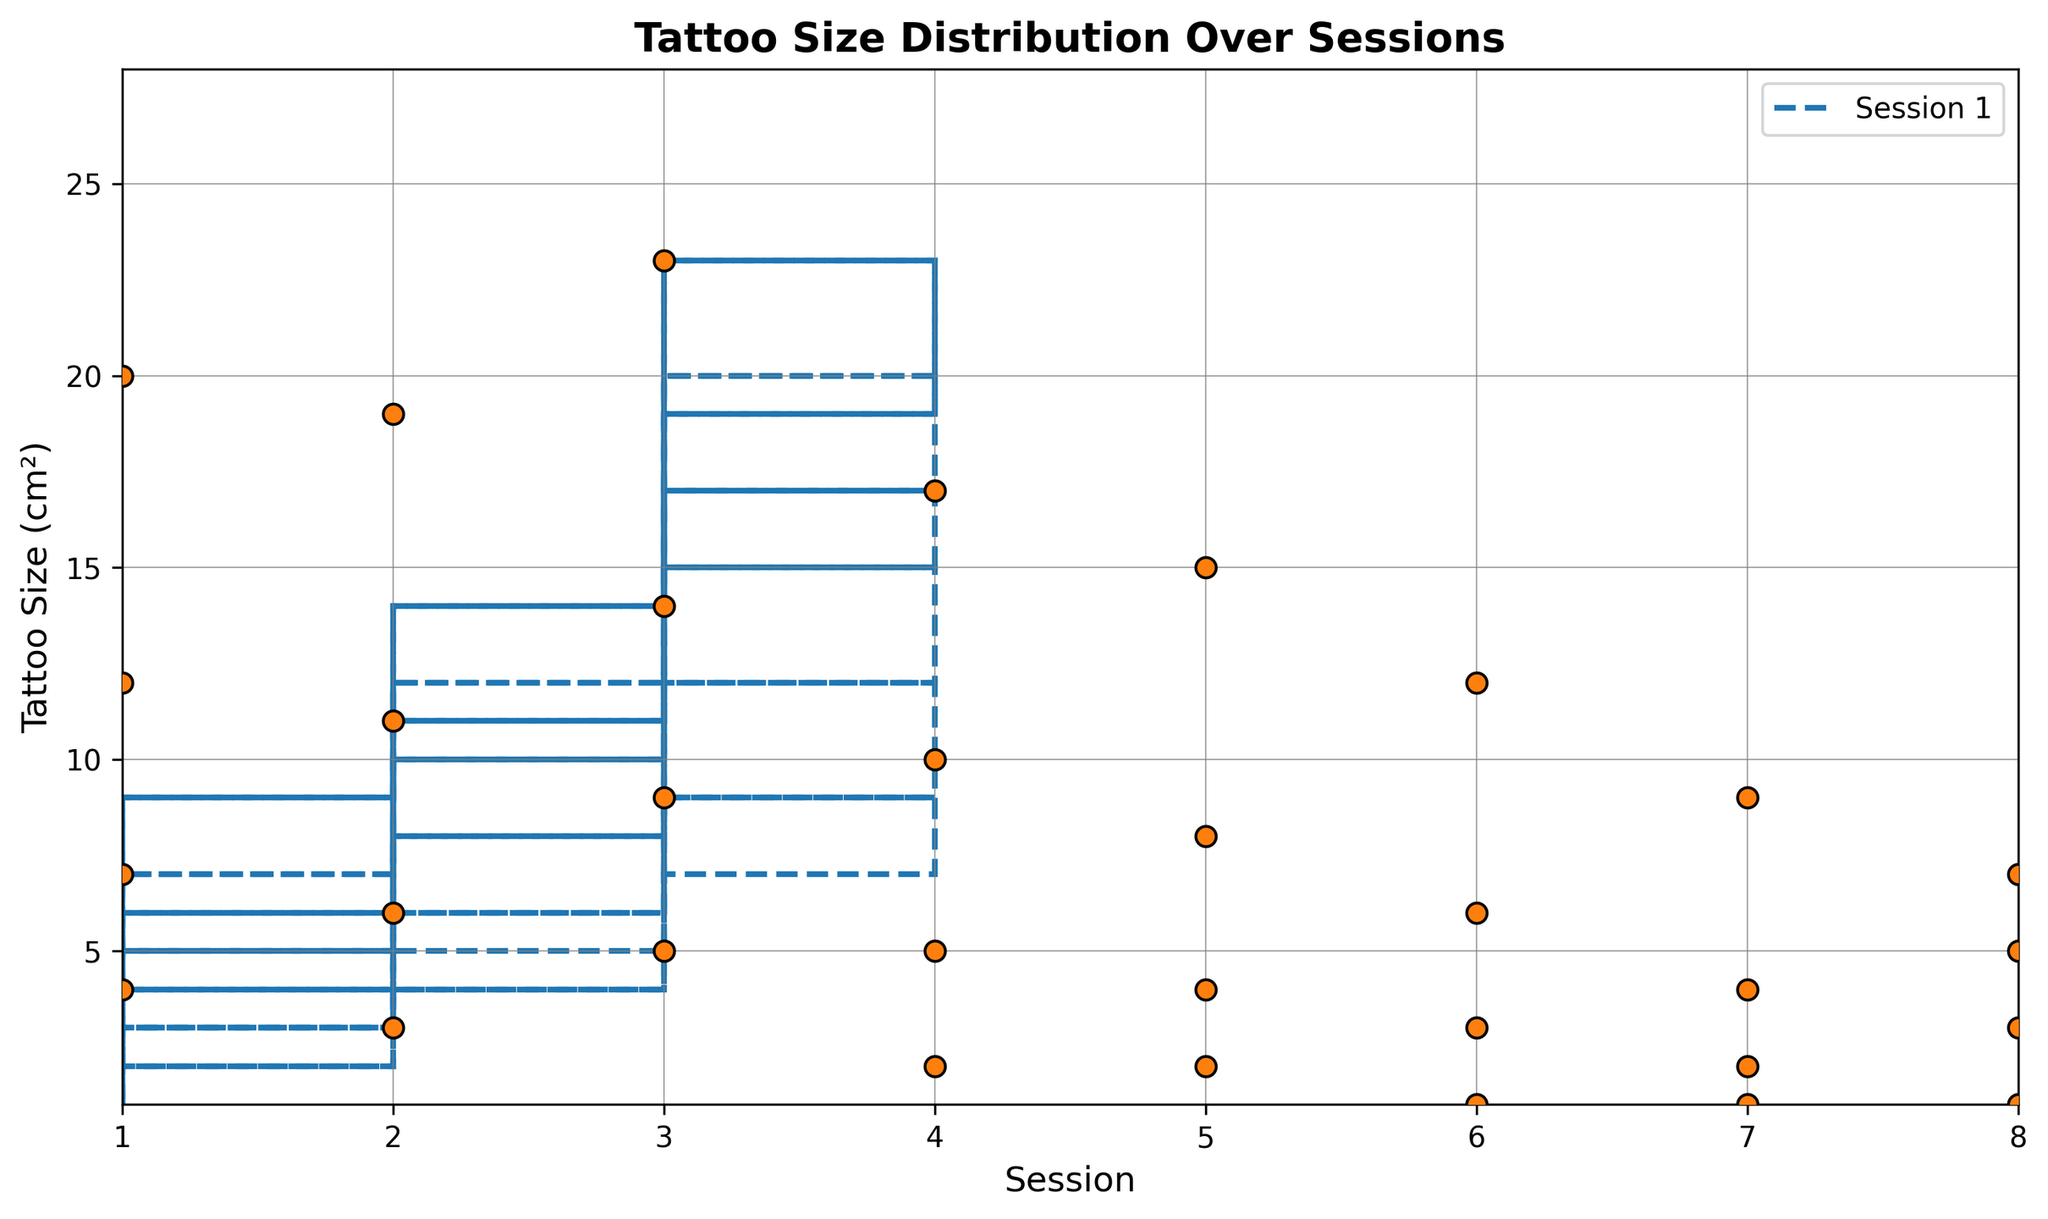How does the size of tattoos change over multiple sessions? The figure shows different tattoo sizes at each session, with a general pattern of decreasing size over successive sessions. By observing the plot, we can see higher sizes in the first few sessions and smaller sizes in subsequent sessions, indicating tattoos are getting smaller over time.
Answer: Tattoos generally decrease in size Which session had the largest tattoo recorded, and what was its size? Look for the highest point on the plot across all sessions. The largest tattoo size appears in session 3 with a size of 23 cm².
Answer: Session 3, 23 cm² What is the median size of tattoos in session 4? In session 4, the sizes are 2, 5, 10, and 17. To find the median, we arrange the sizes in ascending order: 2, 5, 10, 17. Since there are 4 data points, the median is the average of the two middle numbers (5 and 10). (5+10)/2 = 7.5
Answer: 7.5 cm² Which session had the smallest tattoo size, and what was its size? The smallest point on the plot identifies the smallest tattoo size, which occurs in session 6 with a size of 1 cm².
Answer: Session 6, 1 cm² How does the range of tattoo sizes change from session 1 to session 8? Calculate the range by subtracting the minimum size from the maximum size for each session. Session 1's range is 20 - 4 = 16, and session 8's range is 7 - 1 = 6. The range decreases from 16 in session 1 to 6 in session 8.
Answer: The range decreases from 16 to 6 Compare the average tattoo size between session 2 and session 7. Which session had a larger average size? Calculate the average size for both sessions. For session 2: (3 + 6 + 11 + 19)/4 = 9.75. For session 7: (1 + 2 + 4 + 9)/4 = 4. Session 2 has a larger average size.
Answer: Session 2, 9.75 cm² What trend can be observed by looking at the change in tattoo size from one session to the next? Generally, sizes tend to get smaller with more sessions, indicating tattoos are progressively getting removed or reduced in size over successive treatments.
Answer: Sizes tend to get smaller How many sessions had at least one tattoo size greater than 15 cm²? Identify the sessions where a point is located above 15 on the y-axis. Sessions 1, 2, 3, 4, and 5 all have at least one tattoo size greater than 15 cm².
Answer: 5 sessions What is the total number of tattoos observed across all sessions? Count all the data points across sessions. There are 32 data points in total, 4 per session across 8 sessions.
Answer: 32 tattoos Which session shows the greatest variability in tattoo sizes? Compare the variability by looking at the spread of sizes within each session. Session 3 shows the greatest variability with sizes ranging from 5 cm² to 23 cm².
Answer: Session 3 